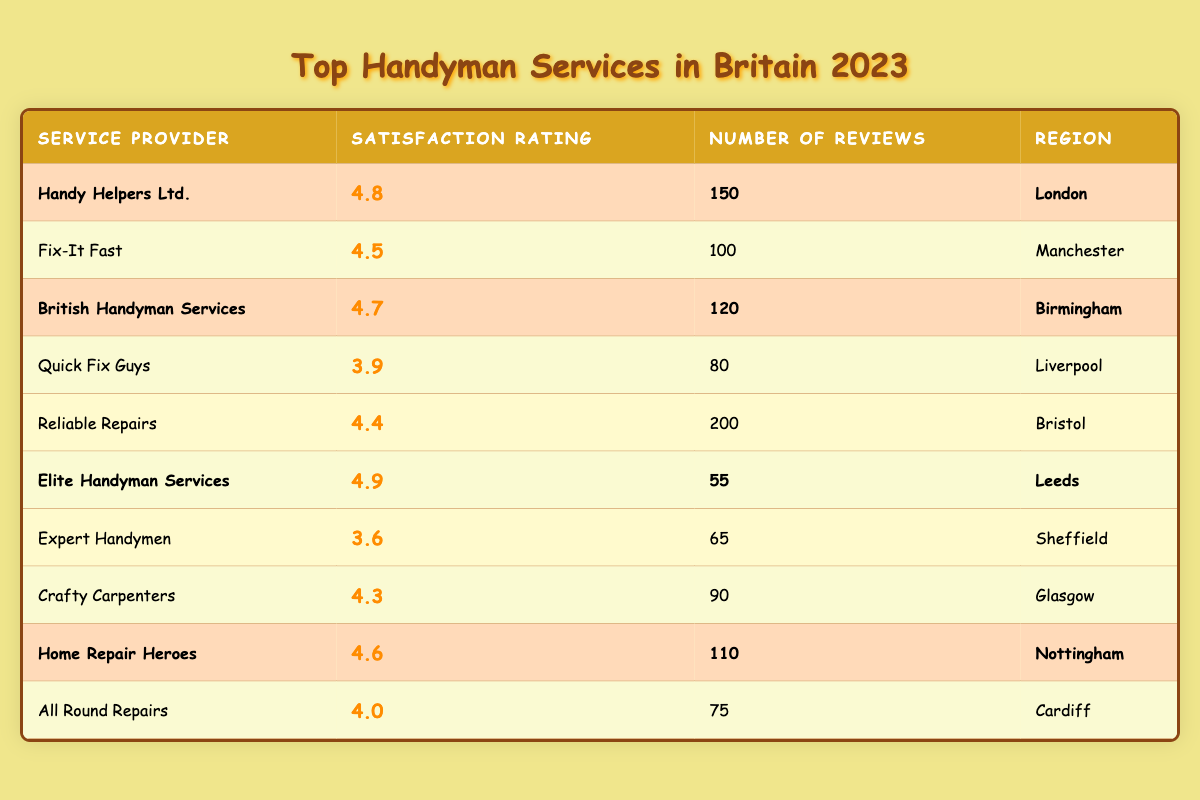What is the highest satisfaction rating among the listed services? The table shows various service providers and their corresponding satisfaction ratings. Scanning through the ratings, I find that "Elite Handyman Services" has the highest rating of 4.9.
Answer: 4.9 Which region has the service provider with the most reviews? The "Reliable Repairs" service has the most reviews, totaling 200, and it is located in Bristol. I can confirm that Bristol has the service provider with the most reviews.
Answer: Bristol How many service providers have a satisfaction rating above 4.5? By reviewing the satisfaction ratings, I see that "Handy Helpers Ltd." (4.8), "British Handyman Services" (4.7), "Elite Handyman Services" (4.9), and "Home Repair Heroes" (4.6) all have ratings above 4.5. In total, that's four providers.
Answer: 4 Is there any service provider from Sheffield that has a satisfaction rating over 4.0? The table shows "Expert Handymen" from Sheffield with a satisfaction rating of 3.6, which is below 4.0. Thus, there are no providers from Sheffield meeting the criteria.
Answer: No What is the average satisfaction rating of the highlighted service providers? The highlighted service providers are "Handy Helpers Ltd." (4.8), "British Handyman Services" (4.7), "Elite Handyman Services" (4.9), and "Home Repair Heroes" (4.6). Adding these ratings gives 4.8 + 4.7 + 4.9 + 4.6 = 19. The average rating is 19 divided by 4, which equals 4.75.
Answer: 4.75 Which service provider has the lowest satisfaction rating and what is that rating? I look at the satisfaction ratings and find "Expert Handymen" with a rating of 3.6, which is the lowest among all the providers listed in the table.
Answer: 3.6 In which region is the service provider with the second-highest number of reviews located? The table shows that the provider with the most reviews is "Reliable Repairs" from Bristol (200 reviews). The second-highest number of reviews is 150 by "Handy Helpers Ltd." from London. Therefore, London is the region of the second-highest reviews.
Answer: London How many service providers have a rating of 4.4 or lower? I can identify the ratings in the table: "Quick Fix Guys" (3.9), "Reliable Repairs" (4.4), and "Expert Handymen" (3.6). Therefore, there are three service providers with ratings of 4.4 or lower.
Answer: 3 Which highlighted service provider operates in Nottingham? In the highlighted section, "Home Repair Heroes" is the service provider listed for Nottingham.
Answer: Home Repair Heroes 